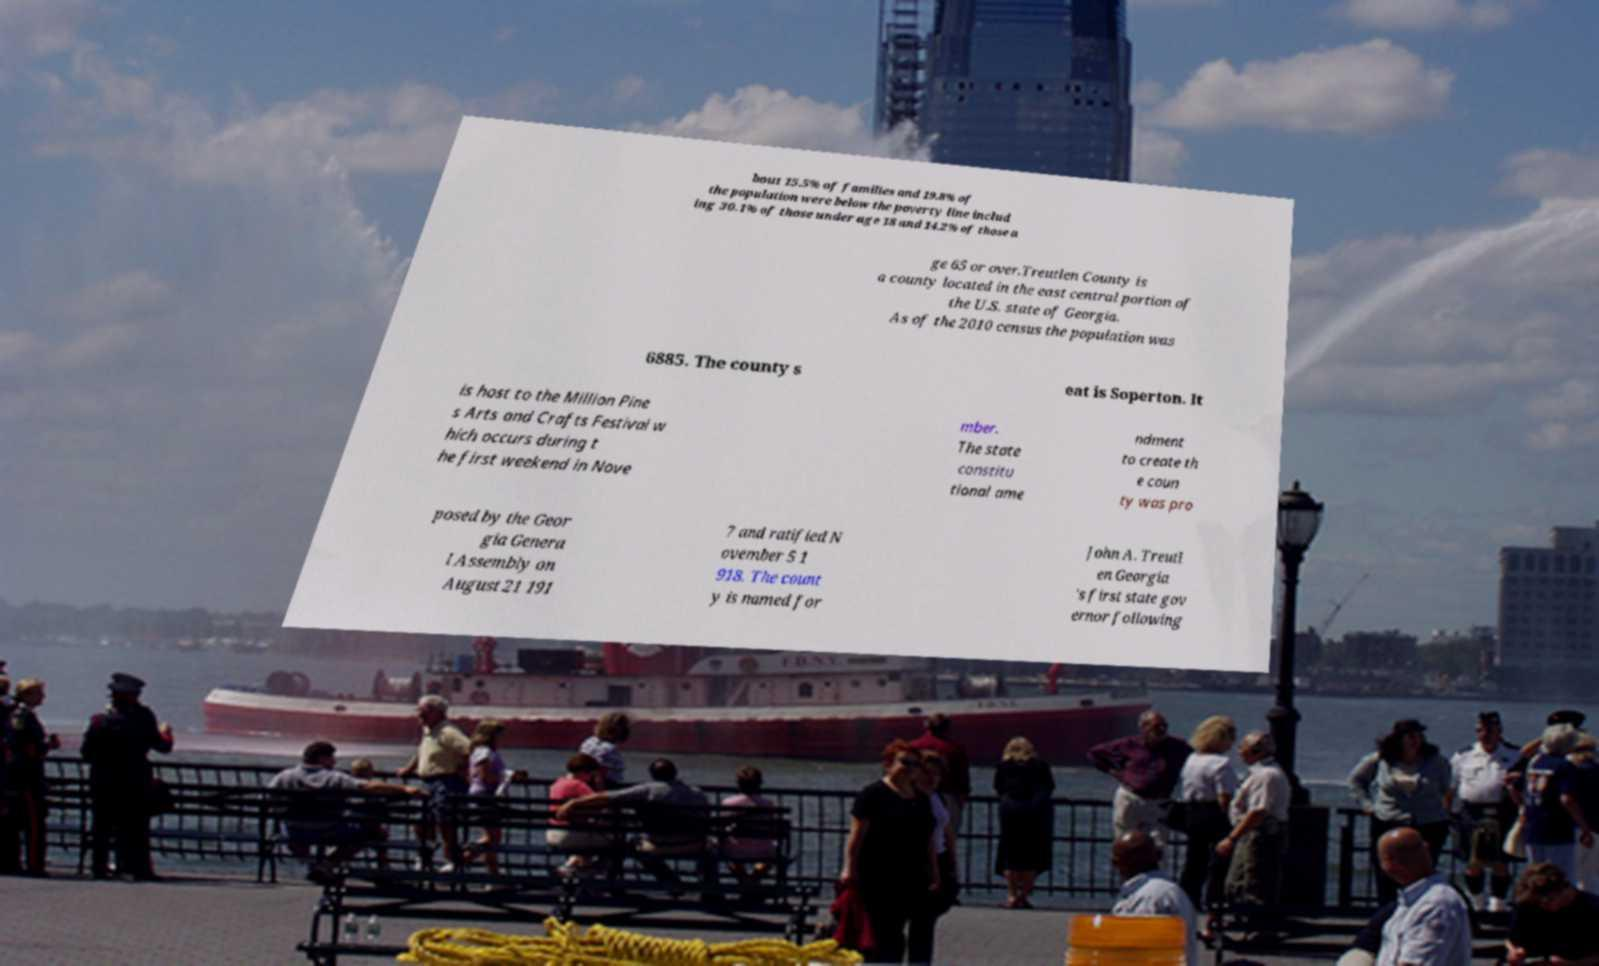Could you assist in decoding the text presented in this image and type it out clearly? bout 15.5% of families and 19.8% of the population were below the poverty line includ ing 30.1% of those under age 18 and 14.2% of those a ge 65 or over.Treutlen County is a county located in the east central portion of the U.S. state of Georgia. As of the 2010 census the population was 6885. The county s eat is Soperton. It is host to the Million Pine s Arts and Crafts Festival w hich occurs during t he first weekend in Nove mber. The state constitu tional ame ndment to create th e coun ty was pro posed by the Geor gia Genera l Assembly on August 21 191 7 and ratified N ovember 5 1 918. The count y is named for John A. Treutl en Georgia 's first state gov ernor following 